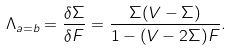Convert formula to latex. <formula><loc_0><loc_0><loc_500><loc_500>\Lambda _ { a = b } = \frac { \delta \Sigma } { \delta F } = \frac { \Sigma ( V - \Sigma ) } { 1 - ( V - 2 \Sigma ) F } .</formula> 